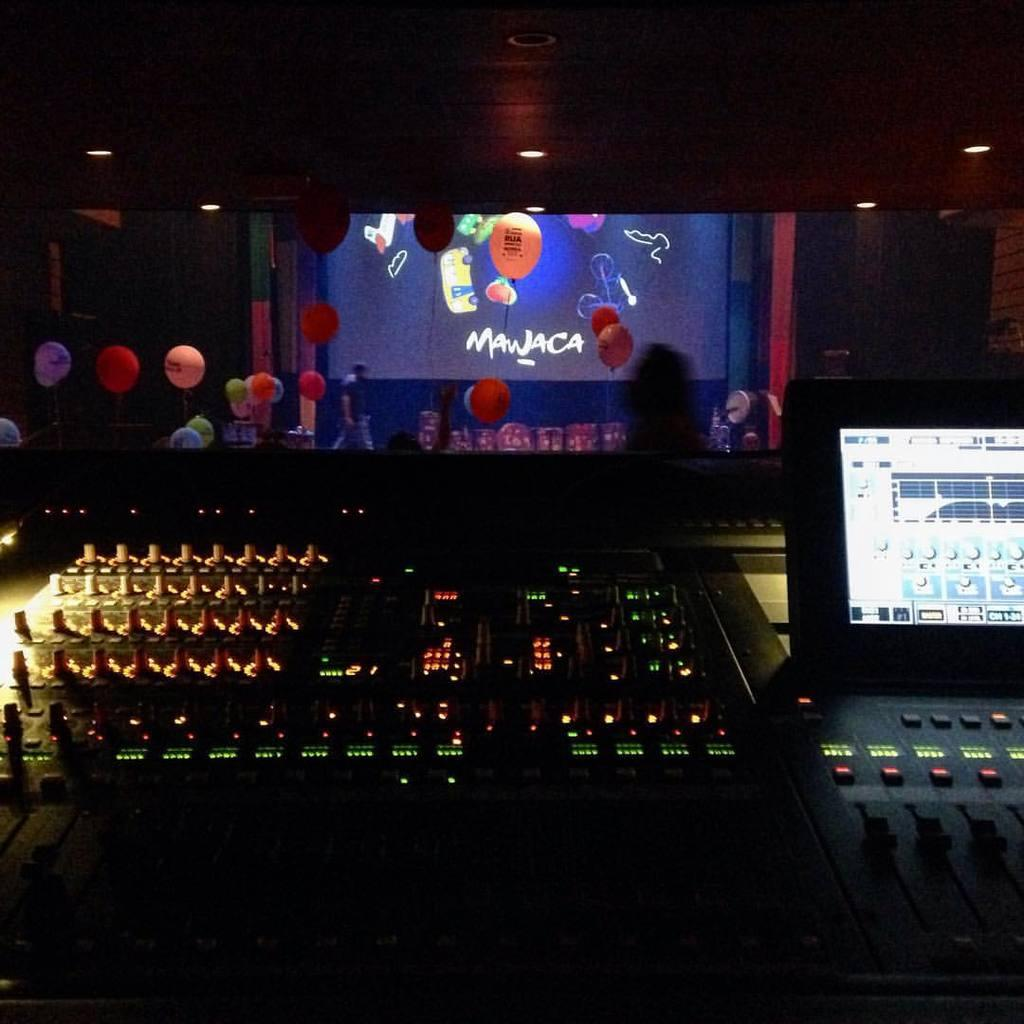What types of objects can be seen in the image? There are devices, balloons, a screen, lights, walls, and people in the image. Can you describe the devices in the image? The provided facts do not specify the type of devices in the image. What is the purpose of the screen in the image? The purpose of the screen in the image cannot be determined from the provided facts. How many people are present in the image? There are people in the image, but the provided facts do not specify the number of people. Are there any cherries or jellyfish visible in the image? There is no mention of cherries or jellyfish in the provided facts, so they are not present in the image. 